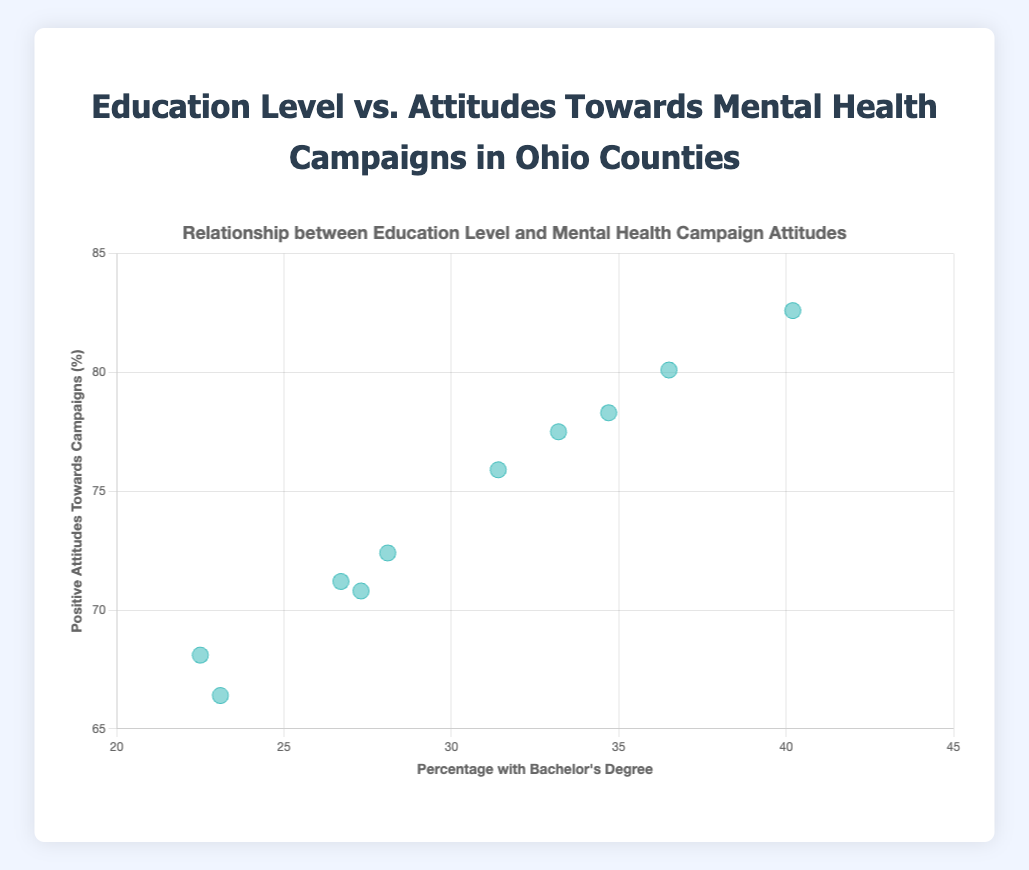How many data points are represented in the scatter plot? Count the individual data points or counties plotted on the scatter plot. There are 10 counties represented, so there are 10 data points.
Answer: 10 Which county has the highest percentage of people with a bachelor’s degree? Identify which county has the highest value on the x-axis. Franklin County has the highest percentage at 40.2%.
Answer: Franklin Which county shows the most positive attitudes towards mental health campaigns? Identify which county has the highest value on the y-axis. Franklin County shows the highest positive attitudes at 82.6%.
Answer: Franklin Is there a county where the percentage with a bachelor’s degree is below 25%? Check the x-axis values to see if any data points are below 25%. Both Stark (22.5%) and Mahoning (23.1%) are below 25%.
Answer: Yes What is the percentage with a bachelor’s degree in Lucas County? Look at the x-axis value corresponding to the data point for Lucas County. Lucas has 27.3% with a bachelor’s degree.
Answer: 27.3% What is the range of positive attitudes towards mental health campaigns across all counties? Find the minimum and maximum values on the y-axis. The range is from 66.4% (Mahoning) to 82.6% (Franklin).
Answer: 66.4% - 82.6% What is the average percentage of positive attitudes towards mental health campaigns for counties with a bachelor's degree percentage above 30%? Sum the positive attitudes for counties with over 30% bachelor’s degrees: Cuyahoga (78.3), Franklin (82.6), Hamilton (80.1), Summit (75.9), and Butler (77.5), then divide by 5. (78.3 + 82.6 + 80.1 + 75.9 + 77.5) / 5 = 78.88.
Answer: 78.88 Which counties have exactly the same percentage of positive attitudes towards mental health campaigns? Identify if any counties share the same y-axis value. None of the counties have exactly the same y-axis value.
Answer: None Is there a visible correlation between the percentage with a bachelor’s degree and positive attitudes towards mental health campaigns? Observe the general trend in the scatter plot; higher bachelor's degree percentages seem to align with higher positive attitudes. There is a positive correlation.
Answer: Yes How much higher is Franklin's positive attitude percentage compared to Mahoning’s? Subtract Mahoning's percentage from Franklin's percentage (82.6 - 66.4). The difference is 16.2%.
Answer: 16.2% 